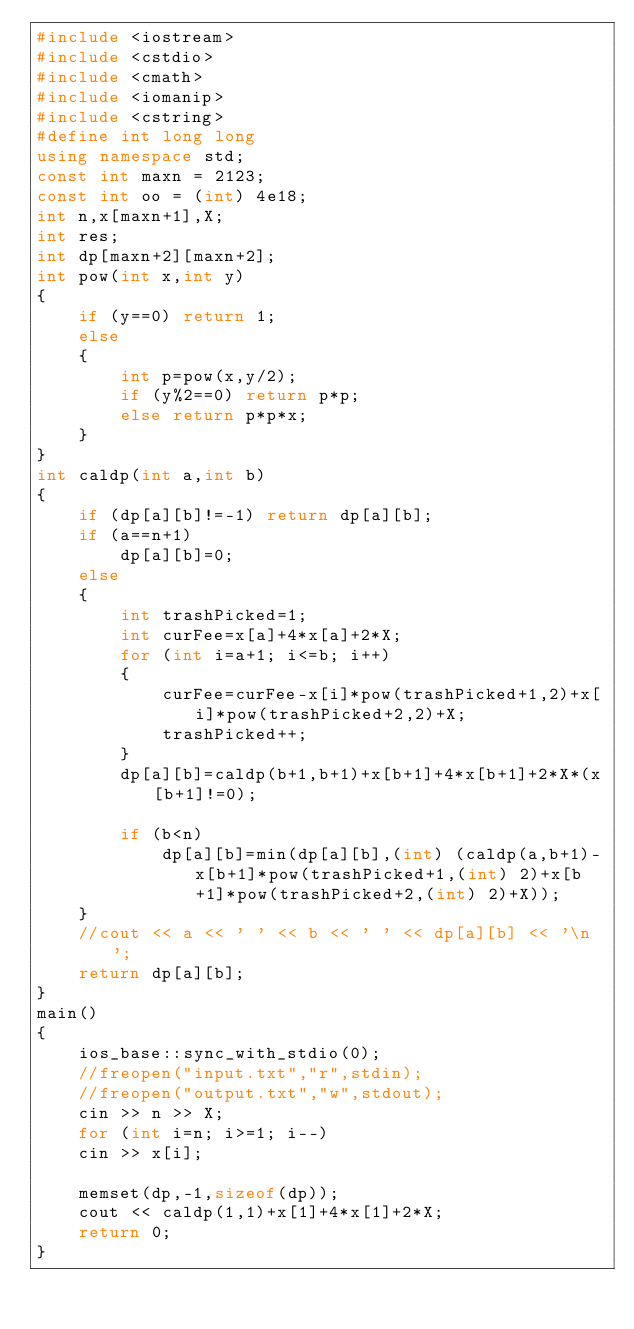<code> <loc_0><loc_0><loc_500><loc_500><_C++_>#include <iostream>
#include <cstdio>
#include <cmath>
#include <iomanip>
#include <cstring>
#define int long long
using namespace std;
const int maxn = 2123;
const int oo = (int) 4e18;
int n,x[maxn+1],X;
int res;
int dp[maxn+2][maxn+2];
int pow(int x,int y)
{
    if (y==0) return 1;
    else
    {
        int p=pow(x,y/2);
        if (y%2==0) return p*p;
        else return p*p*x;
    }
}
int caldp(int a,int b)
{
    if (dp[a][b]!=-1) return dp[a][b];
    if (a==n+1)
        dp[a][b]=0;
    else
    {
        int trashPicked=1;
        int curFee=x[a]+4*x[a]+2*X;
        for (int i=a+1; i<=b; i++)
        {
            curFee=curFee-x[i]*pow(trashPicked+1,2)+x[i]*pow(trashPicked+2,2)+X;
            trashPicked++;
        }
        dp[a][b]=caldp(b+1,b+1)+x[b+1]+4*x[b+1]+2*X*(x[b+1]!=0);

        if (b<n)
            dp[a][b]=min(dp[a][b],(int) (caldp(a,b+1)-x[b+1]*pow(trashPicked+1,(int) 2)+x[b+1]*pow(trashPicked+2,(int) 2)+X));
    }
    //cout << a << ' ' << b << ' ' << dp[a][b] << '\n';
    return dp[a][b];
}
main()
{
    ios_base::sync_with_stdio(0);
    //freopen("input.txt","r",stdin);
    //freopen("output.txt","w",stdout);
    cin >> n >> X;
    for (int i=n; i>=1; i--)
    cin >> x[i];

    memset(dp,-1,sizeof(dp));
    cout << caldp(1,1)+x[1]+4*x[1]+2*X;
    return 0;
}
</code> 